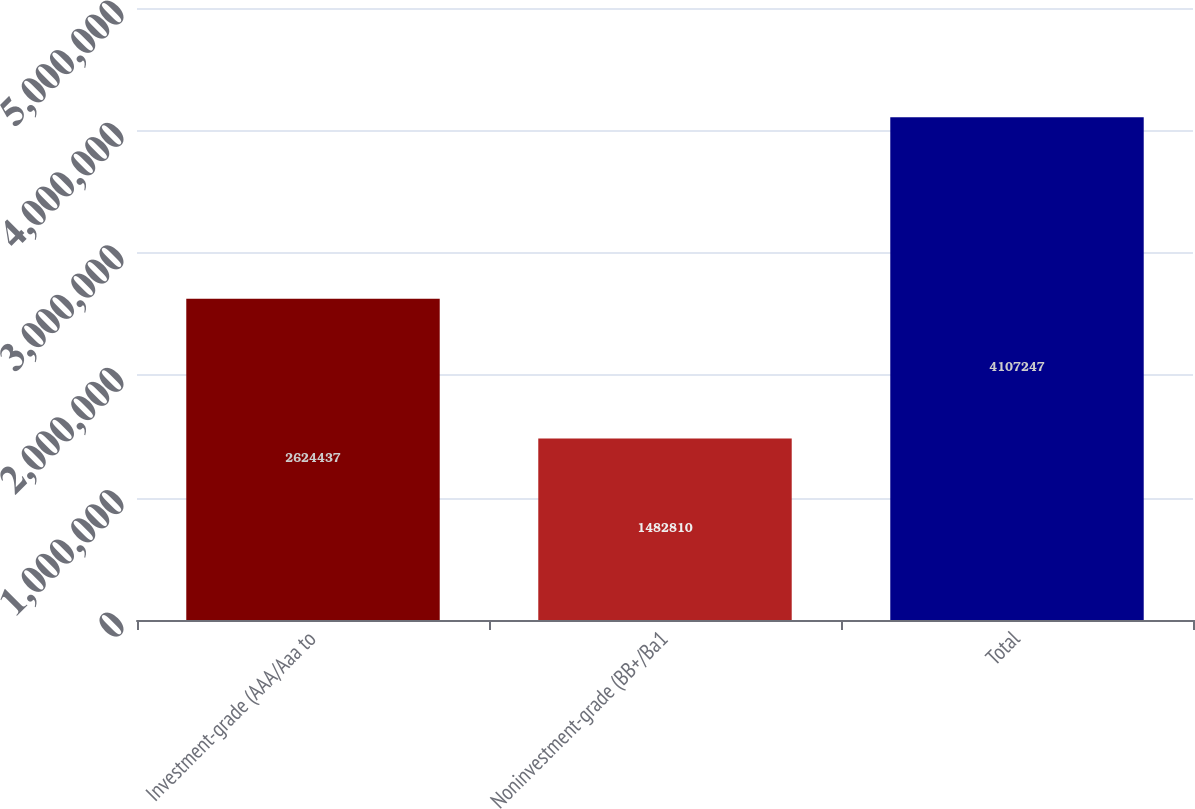<chart> <loc_0><loc_0><loc_500><loc_500><bar_chart><fcel>Investment-grade (AAA/Aaa to<fcel>Noninvestment-grade (BB+/Ba1<fcel>Total<nl><fcel>2.62444e+06<fcel>1.48281e+06<fcel>4.10725e+06<nl></chart> 